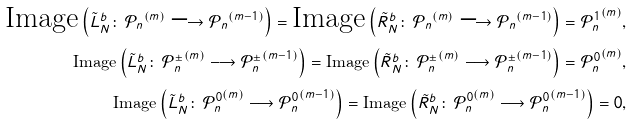<formula> <loc_0><loc_0><loc_500><loc_500>\text {Image} \left ( \tilde { L } _ { N } ^ { b } \colon \, { \mathcal { P } _ { n } } ^ { ( m ) } \longrightarrow { \mathcal { P } _ { n } } ^ { ( m - 1 ) } \right ) = \text {Image} \left ( \tilde { R } _ { N } ^ { b } \colon \, { \mathcal { P } _ { n } } ^ { ( m ) } \longrightarrow { \mathcal { P } _ { n } } ^ { ( m - 1 ) } \right ) = { \mathcal { P } _ { n } ^ { 1 } } ^ { ( m ) } , \\ \text {Image} \left ( \tilde { L } _ { N } ^ { b } \colon \, { \mathcal { P } _ { n } ^ { \pm } } ^ { ( m ) } \longrightarrow { \mathcal { P } _ { n } ^ { \pm } } ^ { ( m - 1 ) } \right ) = \text {Image} \left ( \tilde { R } _ { N } ^ { b } \colon \, { \mathcal { P } _ { n } ^ { \pm } } ^ { ( m ) } \longrightarrow { \mathcal { P } _ { n } ^ { \pm } } ^ { ( m - 1 ) } \right ) = { \mathcal { P } _ { n } ^ { 0 } } ^ { ( m ) } , \\ \text {Image} \left ( \tilde { L } _ { N } ^ { b } \colon \, { \mathcal { P } _ { n } ^ { 0 } } ^ { ( m ) } \longrightarrow { \mathcal { P } _ { n } ^ { 0 } } ^ { ( m - 1 ) } \right ) = \text {Image} \left ( \tilde { R } _ { N } ^ { b } \colon \, { \mathcal { P } _ { n } ^ { 0 } } ^ { ( m ) } \longrightarrow { \mathcal { P } _ { n } ^ { 0 } } ^ { ( m - 1 ) } \right ) = 0 ,</formula> 